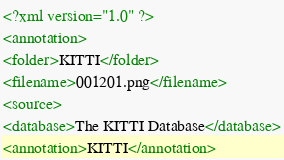Convert code to text. <code><loc_0><loc_0><loc_500><loc_500><_XML_><?xml version="1.0" ?>
<annotation>
<folder>KITTI</folder>
<filename>001201.png</filename>
<source>
<database>The KITTI Database</database>
<annotation>KITTI</annotation></code> 